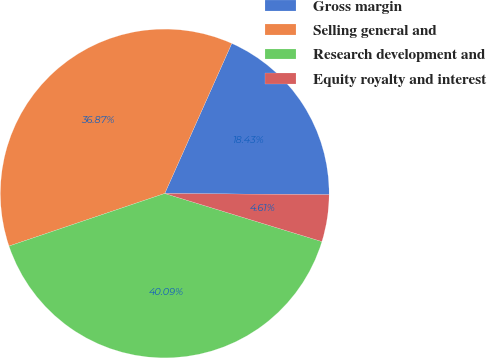Convert chart to OTSL. <chart><loc_0><loc_0><loc_500><loc_500><pie_chart><fcel>Gross margin<fcel>Selling general and<fcel>Research development and<fcel>Equity royalty and interest<nl><fcel>18.43%<fcel>36.87%<fcel>40.09%<fcel>4.61%<nl></chart> 